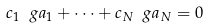Convert formula to latex. <formula><loc_0><loc_0><loc_500><loc_500>c _ { 1 } \ g a _ { 1 } + \dots + c _ { N } \ g a _ { N } = 0</formula> 